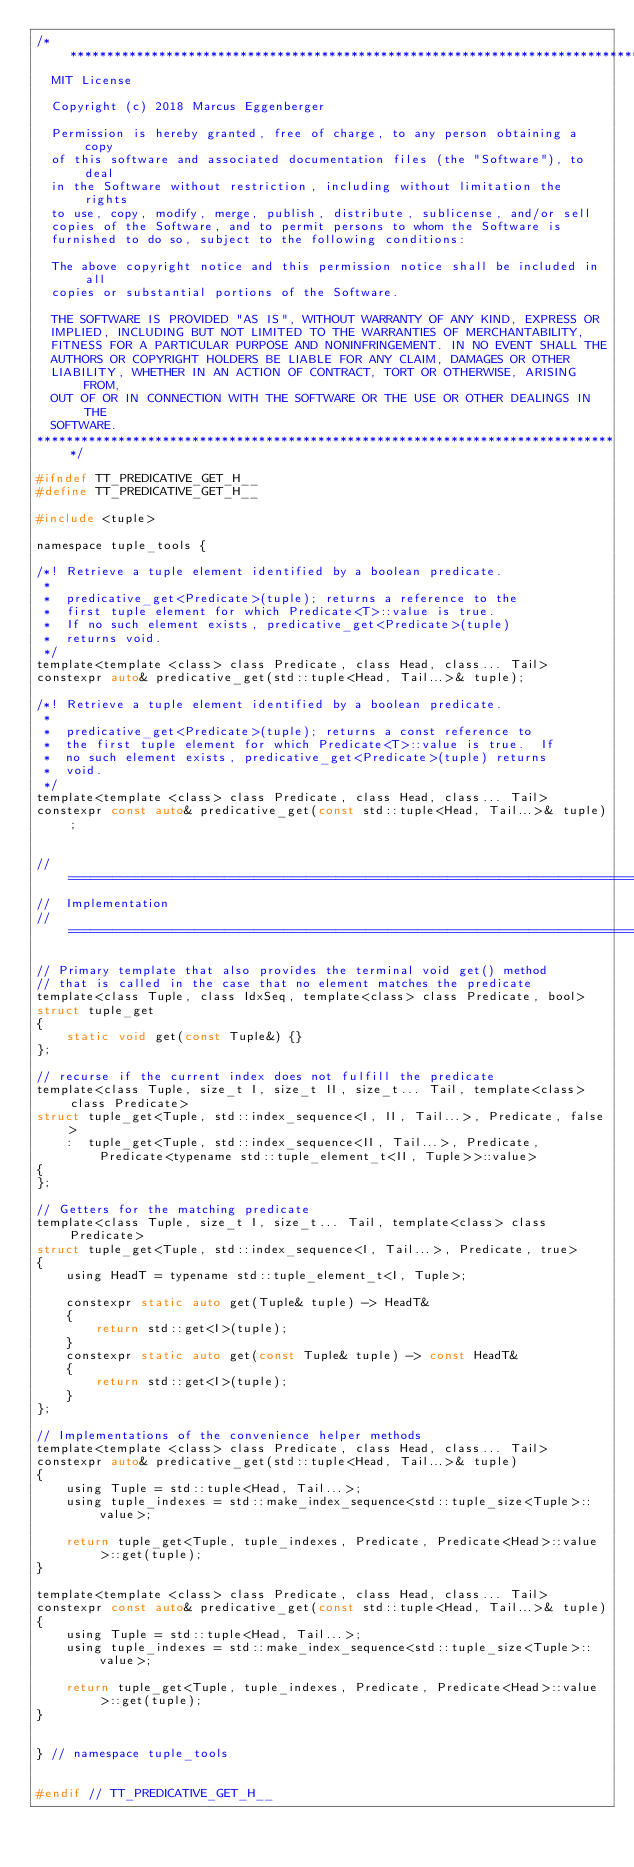<code> <loc_0><loc_0><loc_500><loc_500><_C_>/*******************************************************************************
  MIT License

  Copyright (c) 2018 Marcus Eggenberger

  Permission is hereby granted, free of charge, to any person obtaining a copy
  of this software and associated documentation files (the "Software"), to deal
  in the Software without restriction, including without limitation the rights
  to use, copy, modify, merge, publish, distribute, sublicense, and/or sell
  copies of the Software, and to permit persons to whom the Software is
  furnished to do so, subject to the following conditions:

  The above copyright notice and this permission notice shall be included in all
  copies or substantial portions of the Software.

  THE SOFTWARE IS PROVIDED "AS IS", WITHOUT WARRANTY OF ANY KIND, EXPRESS OR
  IMPLIED, INCLUDING BUT NOT LIMITED TO THE WARRANTIES OF MERCHANTABILITY,
  FITNESS FOR A PARTICULAR PURPOSE AND NONINFRINGEMENT. IN NO EVENT SHALL THE
  AUTHORS OR COPYRIGHT HOLDERS BE LIABLE FOR ANY CLAIM, DAMAGES OR OTHER
  LIABILITY, WHETHER IN AN ACTION OF CONTRACT, TORT OR OTHERWISE, ARISING FROM,
  OUT OF OR IN CONNECTION WITH THE SOFTWARE OR THE USE OR OTHER DEALINGS IN THE
  SOFTWARE.
*******************************************************************************/

#ifndef TT_PREDICATIVE_GET_H__
#define TT_PREDICATIVE_GET_H__

#include <tuple>

namespace tuple_tools {

/*! Retrieve a tuple element identified by a boolean predicate.
 *
 *  predicative_get<Predicate>(tuple); returns a reference to the
 *  first tuple element for which Predicate<T>::value is true.
 *  If no such element exists, predicative_get<Predicate>(tuple)
 *  returns void.
 */
template<template <class> class Predicate, class Head, class... Tail>
constexpr auto& predicative_get(std::tuple<Head, Tail...>& tuple);

/*! Retrieve a tuple element identified by a boolean predicate.
 *
 *  predicative_get<Predicate>(tuple); returns a const reference to
 *  the first tuple element for which Predicate<T>::value is true.  If
 *  no such element exists, predicative_get<Predicate>(tuple) returns
 *  void.
 */
template<template <class> class Predicate, class Head, class... Tail>
constexpr const auto& predicative_get(const std::tuple<Head, Tail...>& tuple);


// ================================================================================
//  Implementation
// ================================================================================

// Primary template that also provides the terminal void get() method
// that is called in the case that no element matches the predicate
template<class Tuple, class IdxSeq, template<class> class Predicate, bool>
struct tuple_get
{
    static void get(const Tuple&) {}
};

// recurse if the current index does not fulfill the predicate
template<class Tuple, size_t I, size_t II, size_t... Tail, template<class> class Predicate>
struct tuple_get<Tuple, std::index_sequence<I, II, Tail...>, Predicate, false>
    :  tuple_get<Tuple, std::index_sequence<II, Tail...>, Predicate, Predicate<typename std::tuple_element_t<II, Tuple>>::value>
{
};

// Getters for the matching predicate
template<class Tuple, size_t I, size_t... Tail, template<class> class Predicate>
struct tuple_get<Tuple, std::index_sequence<I, Tail...>, Predicate, true>
{
    using HeadT = typename std::tuple_element_t<I, Tuple>;

    constexpr static auto get(Tuple& tuple) -> HeadT&
    {
        return std::get<I>(tuple);
    }
    constexpr static auto get(const Tuple& tuple) -> const HeadT&
    {
        return std::get<I>(tuple);
    }
};

// Implementations of the convenience helper methods
template<template <class> class Predicate, class Head, class... Tail>
constexpr auto& predicative_get(std::tuple<Head, Tail...>& tuple)
{
    using Tuple = std::tuple<Head, Tail...>;
    using tuple_indexes = std::make_index_sequence<std::tuple_size<Tuple>::value>;

    return tuple_get<Tuple, tuple_indexes, Predicate, Predicate<Head>::value>::get(tuple);
}

template<template <class> class Predicate, class Head, class... Tail>
constexpr const auto& predicative_get(const std::tuple<Head, Tail...>& tuple)
{
    using Tuple = std::tuple<Head, Tail...>;
    using tuple_indexes = std::make_index_sequence<std::tuple_size<Tuple>::value>;

    return tuple_get<Tuple, tuple_indexes, Predicate, Predicate<Head>::value>::get(tuple);
}


} // namespace tuple_tools


#endif // TT_PREDICATIVE_GET_H__
</code> 